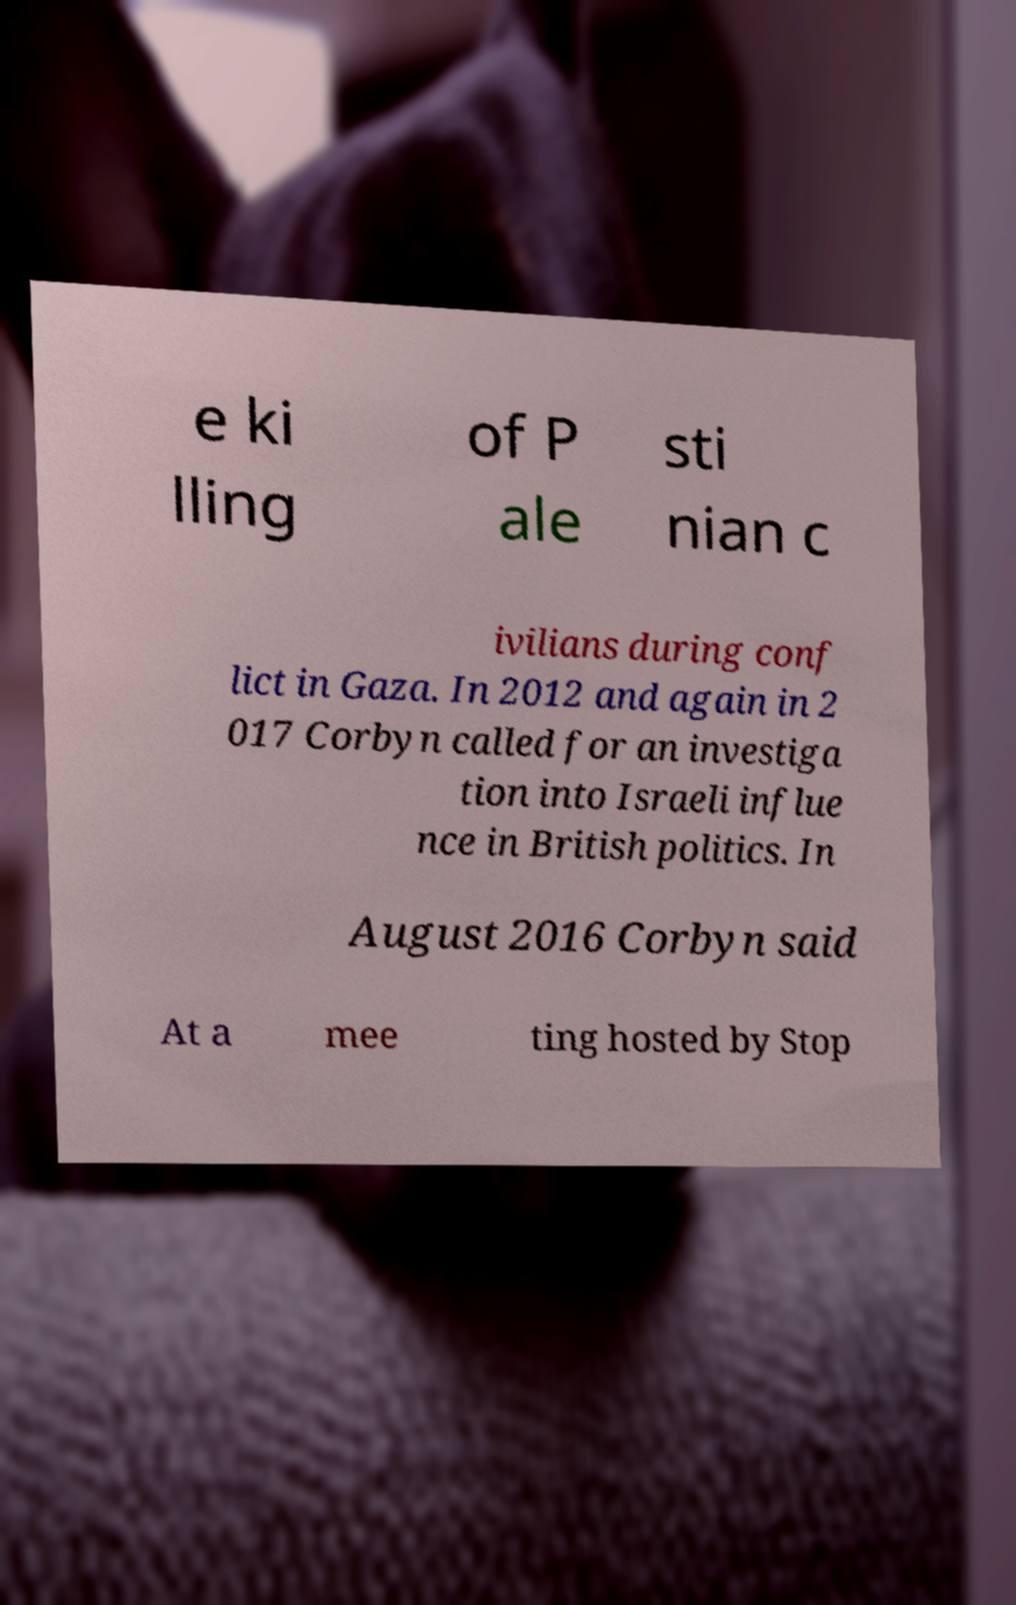Could you assist in decoding the text presented in this image and type it out clearly? e ki lling of P ale sti nian c ivilians during conf lict in Gaza. In 2012 and again in 2 017 Corbyn called for an investiga tion into Israeli influe nce in British politics. In August 2016 Corbyn said At a mee ting hosted by Stop 